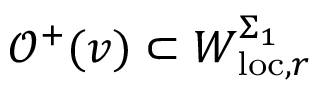Convert formula to latex. <formula><loc_0><loc_0><loc_500><loc_500>\mathcal { O } ^ { + } ( v ) \subset W _ { l o c , r } ^ { \Sigma _ { 1 } }</formula> 